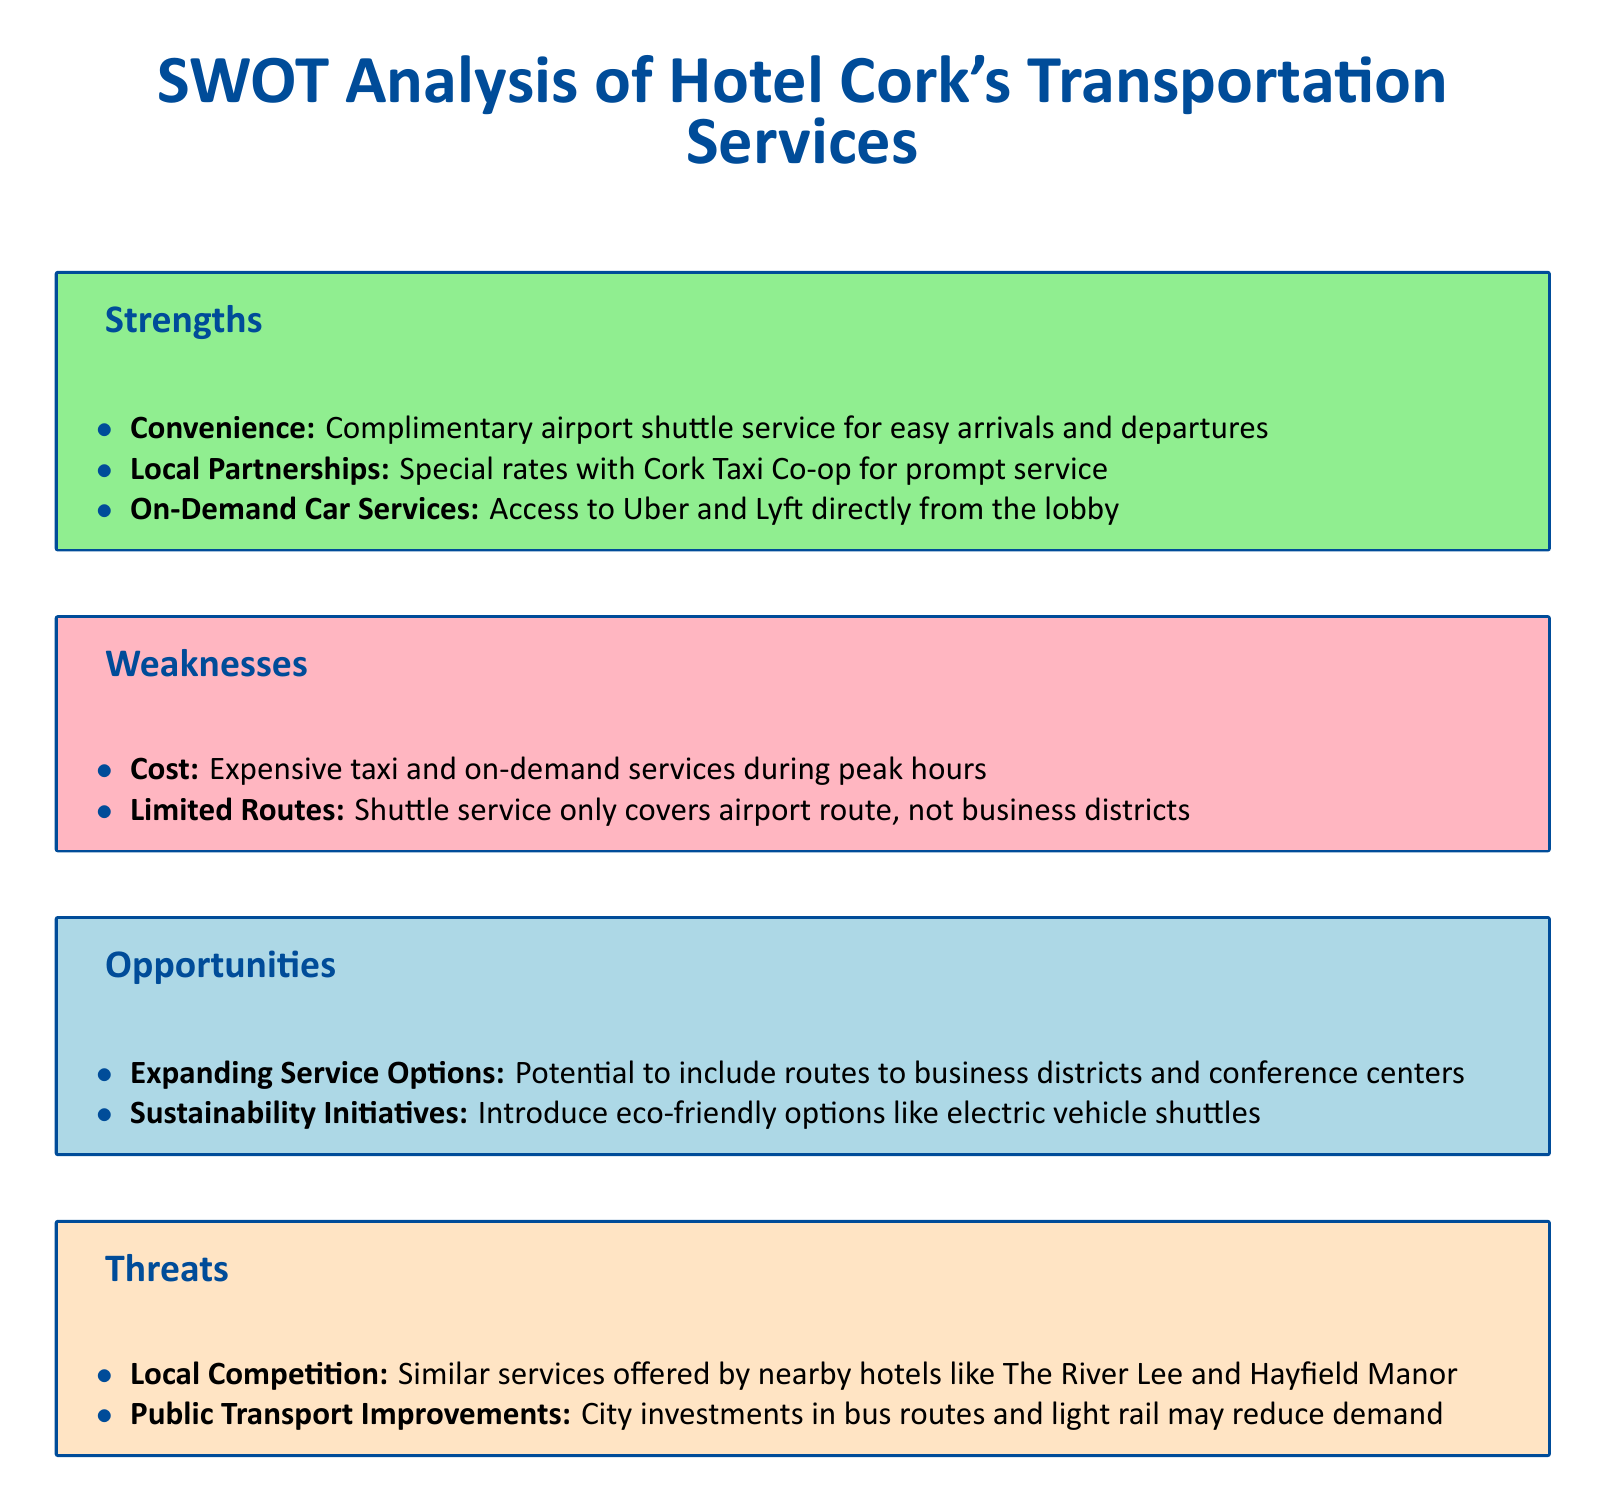What is offered for easy arrivals and departures? The document states that there is a complimentary airport shuttle service for easy arrivals and departures.
Answer: Complimentary airport shuttle service What partnerships does the hotel have for transportation? It mentions a special rate with Cork Taxi Co-op for prompt service.
Answer: Cork Taxi Co-op What is a weakness related to cost mentioned in the document? The document states that there are expensive taxi and on-demand services during peak hours.
Answer: Expensive taxi and on-demand services What are the proposed eco-friendly options for transportation? The document highlights introducing eco-friendly options like electric vehicle shuttles as an opportunity.
Answer: Electric vehicle shuttles Which local hotels pose a threat due to similar services? The document lists nearby hotels like The River Lee and Hayfield Manor as competition.
Answer: The River Lee and Hayfield Manor What type of improvements could reduce demand for hotel transportation? The document states that city investments in public transport improvements may reduce demand.
Answer: Public transport improvements What area is not covered by the hotel shuttle service? The document indicates that the shuttle service does not cover business districts.
Answer: Business districts What opportunity involves expanding routes? The document mentions potential to include routes to business districts and conference centers as an opportunity.
Answer: Routes to business districts and conference centers 